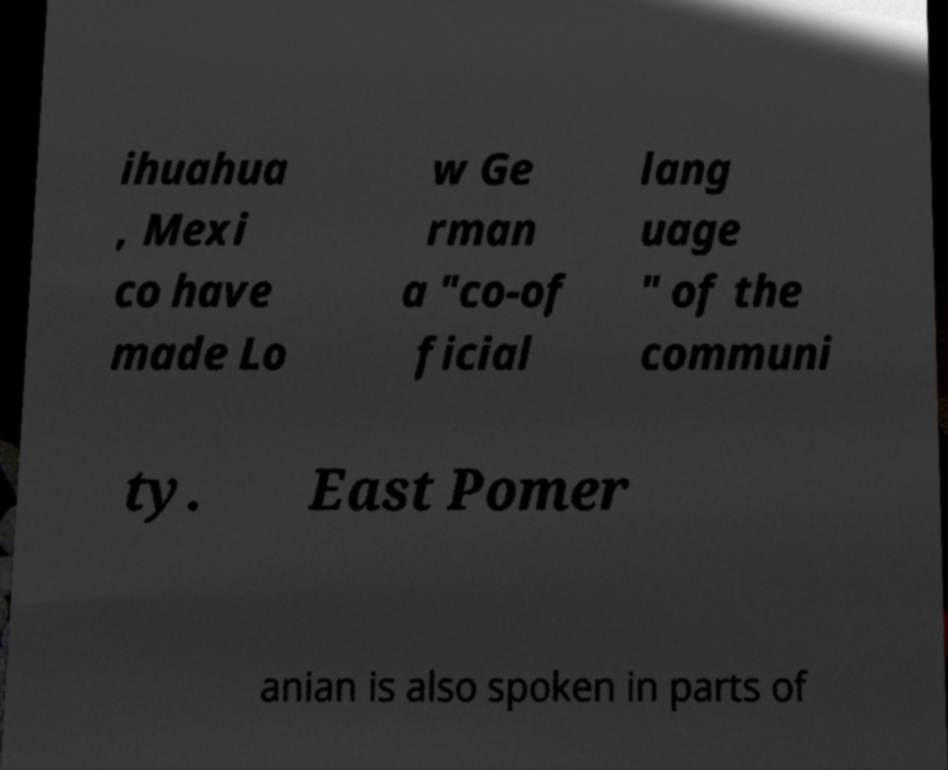Can you read and provide the text displayed in the image?This photo seems to have some interesting text. Can you extract and type it out for me? ihuahua , Mexi co have made Lo w Ge rman a "co-of ficial lang uage " of the communi ty. East Pomer anian is also spoken in parts of 